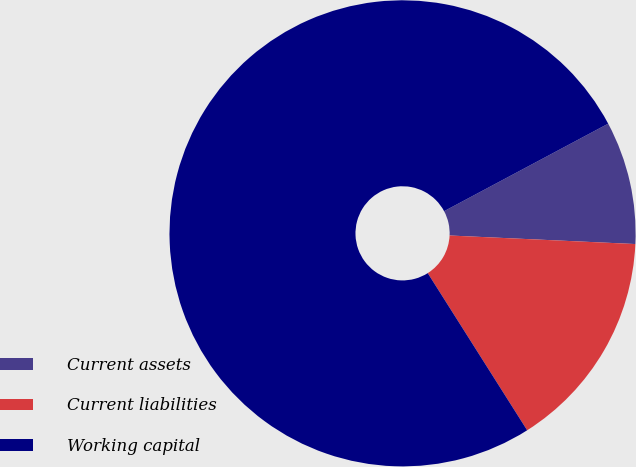Convert chart. <chart><loc_0><loc_0><loc_500><loc_500><pie_chart><fcel>Current assets<fcel>Current liabilities<fcel>Working capital<nl><fcel>8.53%<fcel>15.29%<fcel>76.18%<nl></chart> 